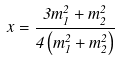Convert formula to latex. <formula><loc_0><loc_0><loc_500><loc_500>x = \frac { 3 m _ { 1 } ^ { 2 } + m _ { 2 } ^ { 2 } } { 4 \left ( m _ { 1 } ^ { 2 } + m _ { 2 } ^ { 2 } \right ) }</formula> 